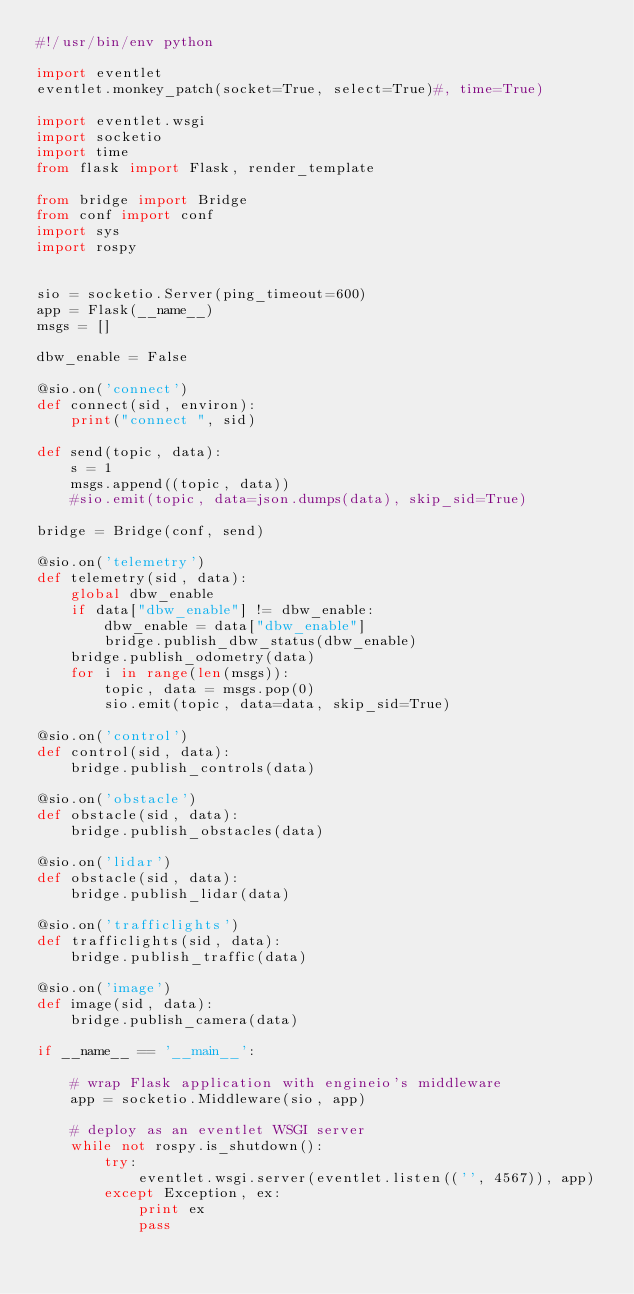<code> <loc_0><loc_0><loc_500><loc_500><_Python_>#!/usr/bin/env python

import eventlet
eventlet.monkey_patch(socket=True, select=True)#, time=True)

import eventlet.wsgi
import socketio
import time
from flask import Flask, render_template

from bridge import Bridge
from conf import conf
import sys
import rospy


sio = socketio.Server(ping_timeout=600)
app = Flask(__name__)
msgs = []

dbw_enable = False

@sio.on('connect')
def connect(sid, environ):
    print("connect ", sid)

def send(topic, data):
    s = 1
    msgs.append((topic, data))
    #sio.emit(topic, data=json.dumps(data), skip_sid=True)

bridge = Bridge(conf, send)

@sio.on('telemetry')
def telemetry(sid, data):
    global dbw_enable
    if data["dbw_enable"] != dbw_enable:
        dbw_enable = data["dbw_enable"]
        bridge.publish_dbw_status(dbw_enable)
    bridge.publish_odometry(data)
    for i in range(len(msgs)):
        topic, data = msgs.pop(0)
        sio.emit(topic, data=data, skip_sid=True)

@sio.on('control')
def control(sid, data):
    bridge.publish_controls(data)

@sio.on('obstacle')
def obstacle(sid, data):
    bridge.publish_obstacles(data)

@sio.on('lidar')
def obstacle(sid, data):
    bridge.publish_lidar(data)

@sio.on('trafficlights')
def trafficlights(sid, data):
    bridge.publish_traffic(data)

@sio.on('image')
def image(sid, data):
    bridge.publish_camera(data)

if __name__ == '__main__':

    # wrap Flask application with engineio's middleware
    app = socketio.Middleware(sio, app)

    # deploy as an eventlet WSGI server
    while not rospy.is_shutdown():
        try:
            eventlet.wsgi.server(eventlet.listen(('', 4567)), app)
        except Exception, ex:
            print ex
            pass
</code> 